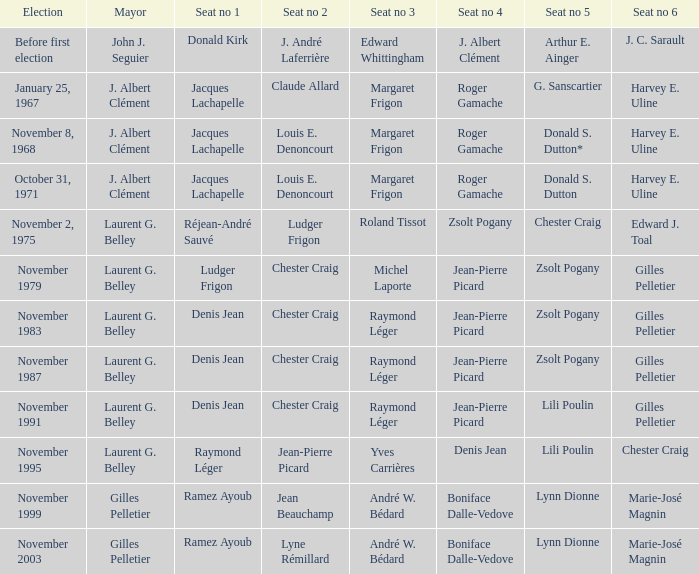If seat no 1 had jacques lachapelle and seat no 5 had donald s. dutton, who was the person sitting in seat no 6? Harvey E. Uline. 